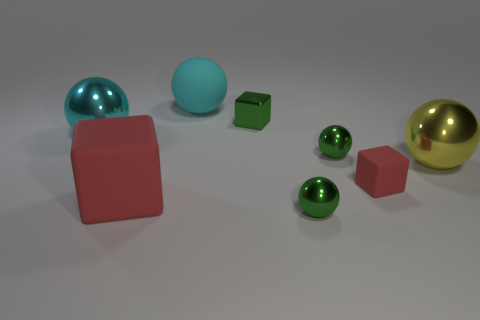Is there anything else that is the same material as the small green cube?
Offer a terse response. Yes. Is the number of matte things behind the shiny block the same as the number of big rubber cubes that are behind the large cyan metal ball?
Ensure brevity in your answer.  No. Does the yellow thing have the same material as the tiny red cube?
Provide a short and direct response. No. What number of green objects are either small objects or big metal balls?
Your response must be concise. 3. How many tiny green metal objects have the same shape as the large red thing?
Your answer should be compact. 1. What material is the yellow ball?
Your answer should be compact. Metal. Are there an equal number of green shiny cubes that are behind the cyan rubber object and red rubber objects?
Your answer should be very brief. No. What shape is the cyan matte thing that is the same size as the yellow shiny thing?
Give a very brief answer. Sphere. There is a green shiny block behind the small matte cube; are there any big shiny things that are on the left side of it?
Provide a short and direct response. Yes. How many small things are either yellow cylinders or shiny spheres?
Your response must be concise. 2. 